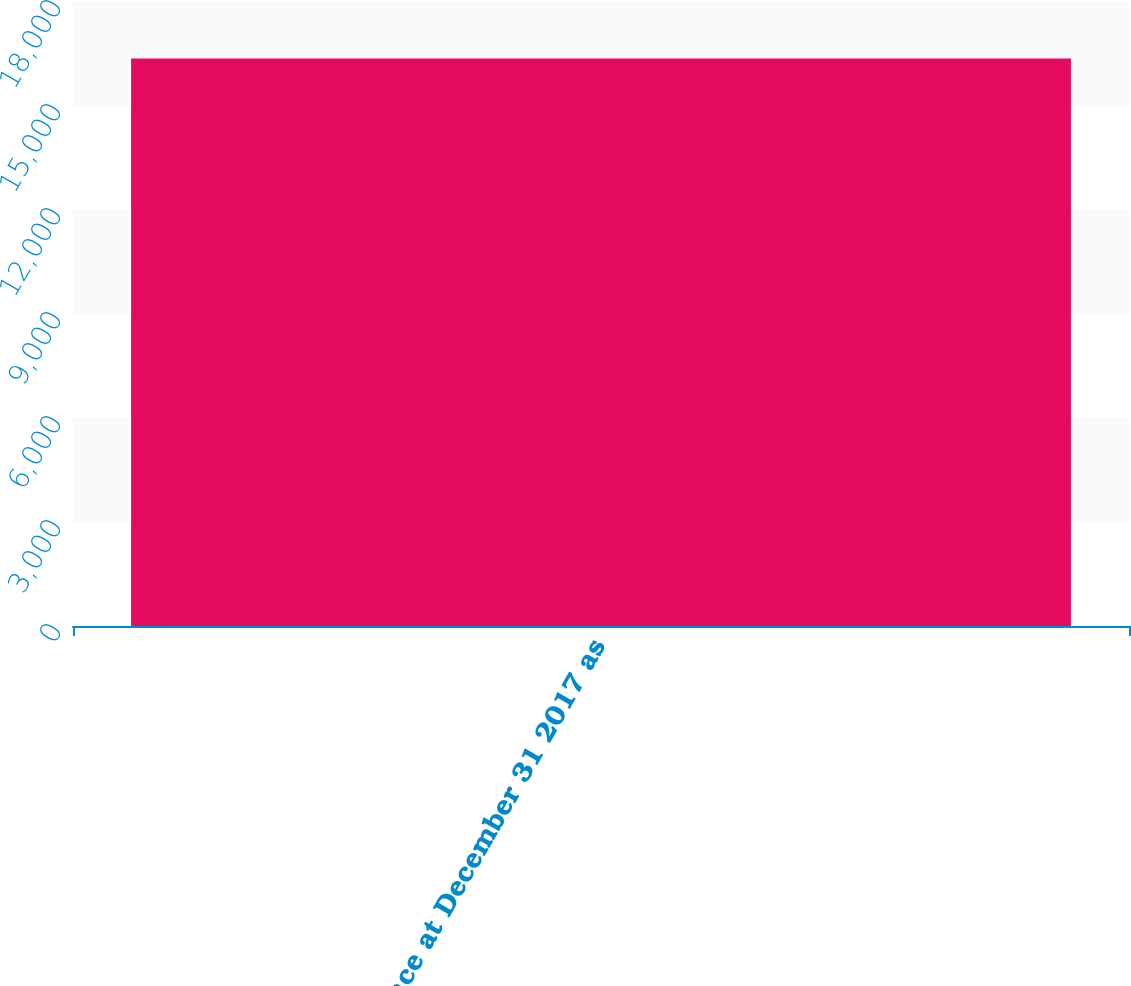Convert chart to OTSL. <chart><loc_0><loc_0><loc_500><loc_500><bar_chart><fcel>Balance at December 31 2017 as<nl><fcel>16373<nl></chart> 